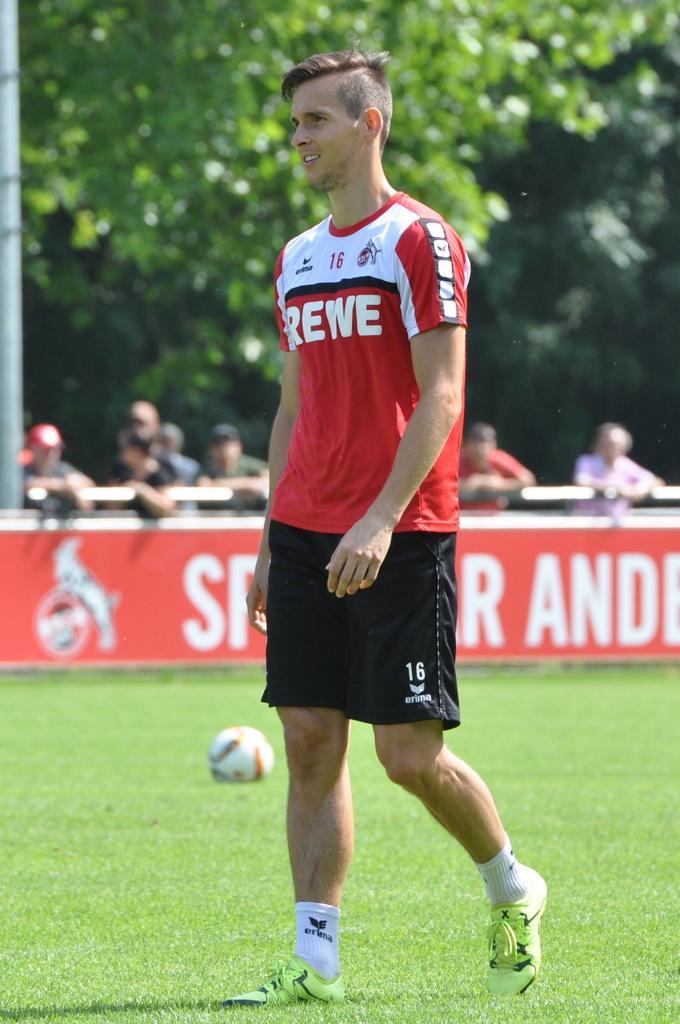How would you summarize this image in a sentence or two? In this image we can see a man is standing on the ground, he is wearing the red t-shirt, there is the ball, there are the group of people standing, here are the trees. 